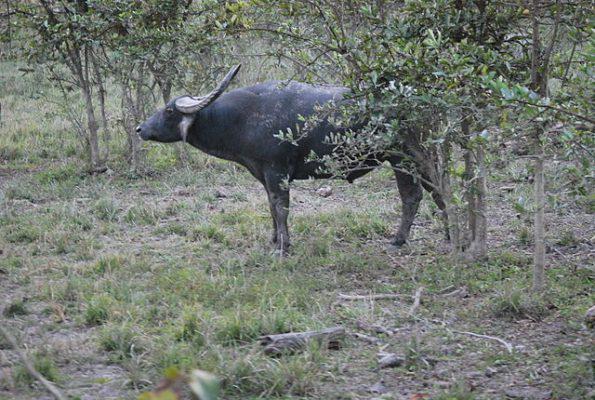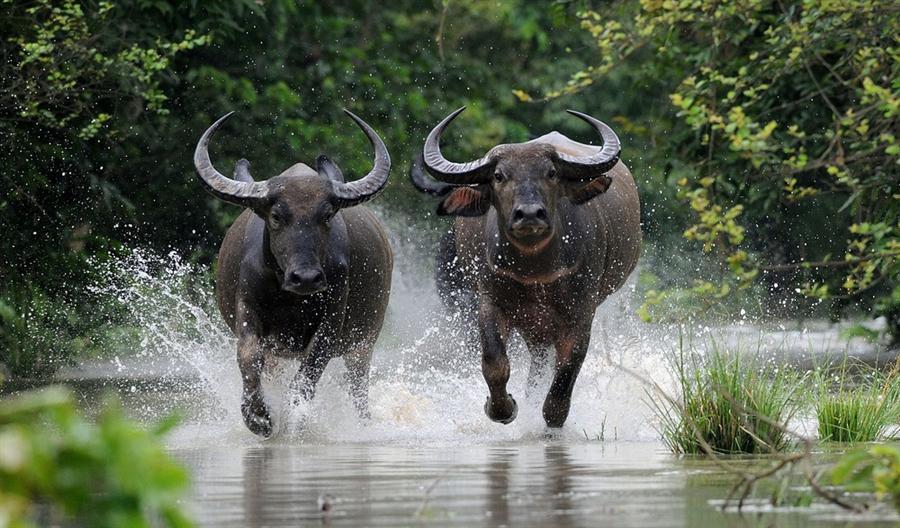The first image is the image on the left, the second image is the image on the right. Considering the images on both sides, is "A calf has its head and neck bent under a standing adult horned animal to nurse." valid? Answer yes or no. No. The first image is the image on the left, the second image is the image on the right. Analyze the images presented: Is the assertion "There are three water buffalo's." valid? Answer yes or no. Yes. 